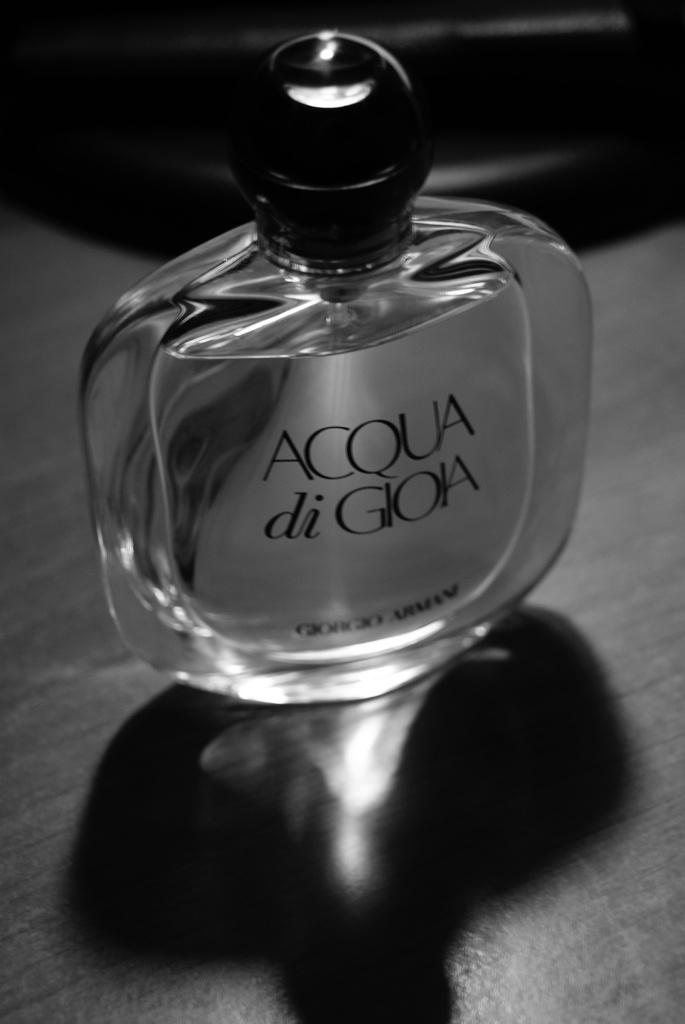<image>
Render a clear and concise summary of the photo. A bottle of perfume sitting on a table and the bottle is labeled Acqua di Gioia. 